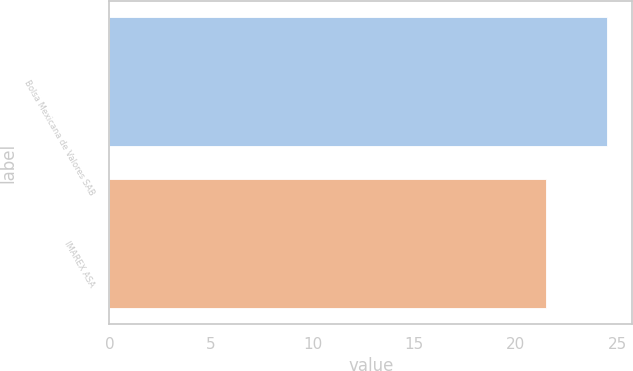Convert chart to OTSL. <chart><loc_0><loc_0><loc_500><loc_500><bar_chart><fcel>Bolsa Mexicana de Valores SAB<fcel>IMAREX ASA<nl><fcel>24.5<fcel>21.5<nl></chart> 